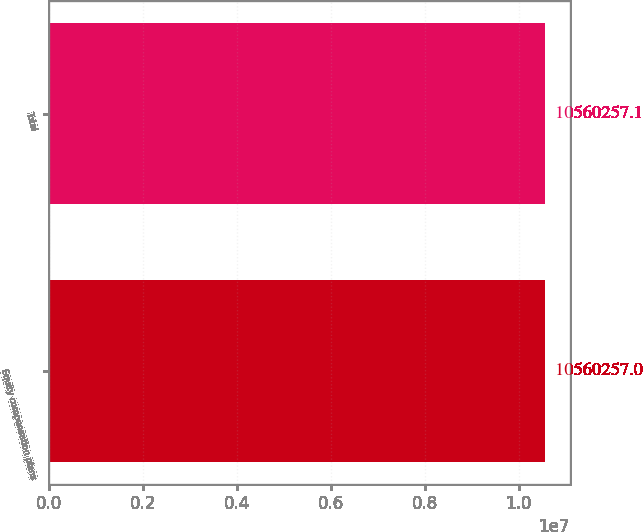<chart> <loc_0><loc_0><loc_500><loc_500><bar_chart><fcel>Equity compensation plans<fcel>Total<nl><fcel>1.05603e+07<fcel>1.05603e+07<nl></chart> 